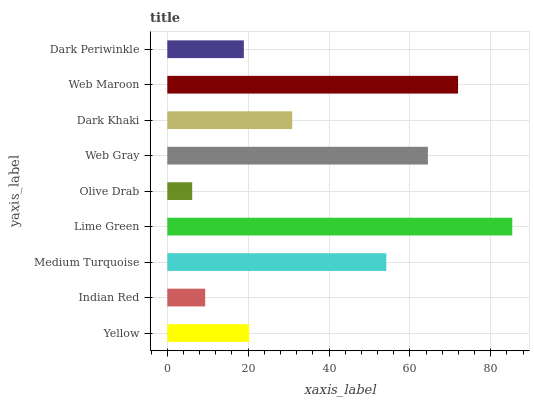Is Olive Drab the minimum?
Answer yes or no. Yes. Is Lime Green the maximum?
Answer yes or no. Yes. Is Indian Red the minimum?
Answer yes or no. No. Is Indian Red the maximum?
Answer yes or no. No. Is Yellow greater than Indian Red?
Answer yes or no. Yes. Is Indian Red less than Yellow?
Answer yes or no. Yes. Is Indian Red greater than Yellow?
Answer yes or no. No. Is Yellow less than Indian Red?
Answer yes or no. No. Is Dark Khaki the high median?
Answer yes or no. Yes. Is Dark Khaki the low median?
Answer yes or no. Yes. Is Olive Drab the high median?
Answer yes or no. No. Is Lime Green the low median?
Answer yes or no. No. 